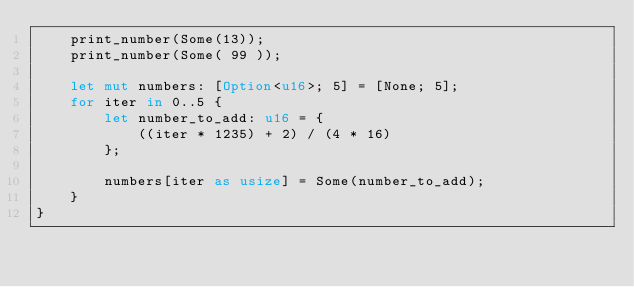Convert code to text. <code><loc_0><loc_0><loc_500><loc_500><_Rust_>    print_number(Some(13));
    print_number(Some( 99 ));

    let mut numbers: [Option<u16>; 5] = [None; 5];
    for iter in 0..5 {
        let number_to_add: u16 = {
            ((iter * 1235) + 2) / (4 * 16)
        };

        numbers[iter as usize] = Some(number_to_add);
    }
}
</code> 